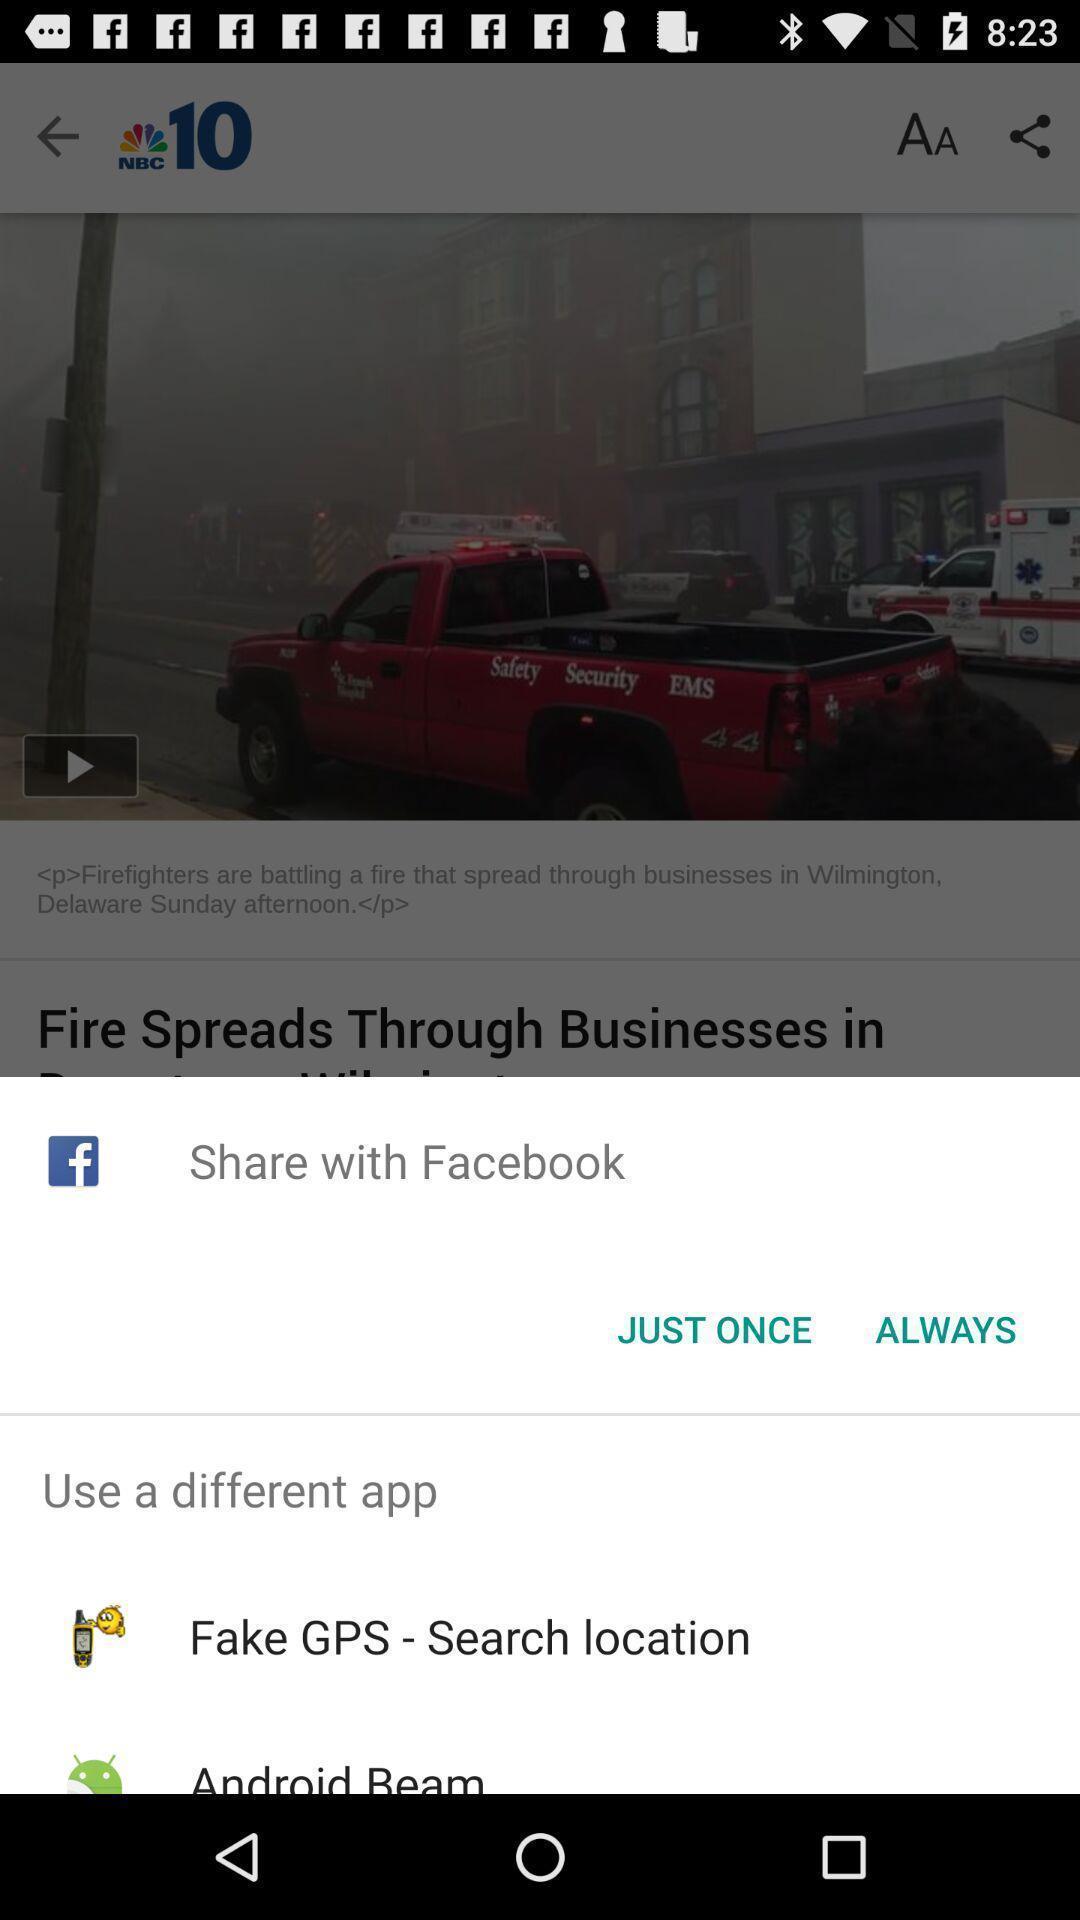Provide a textual representation of this image. Pop-up shows to share with social app. 